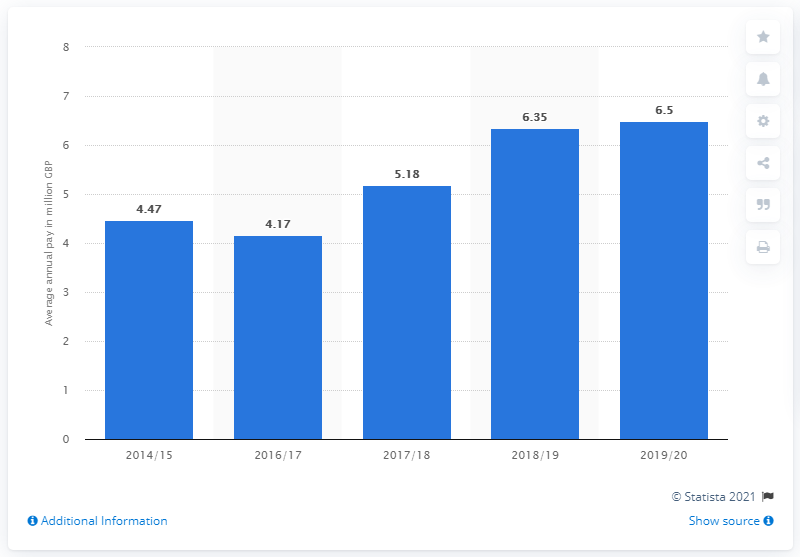Identify some key points in this picture. The average salary of the first team players during the 2019/20 season was 6.5 million dollars. 